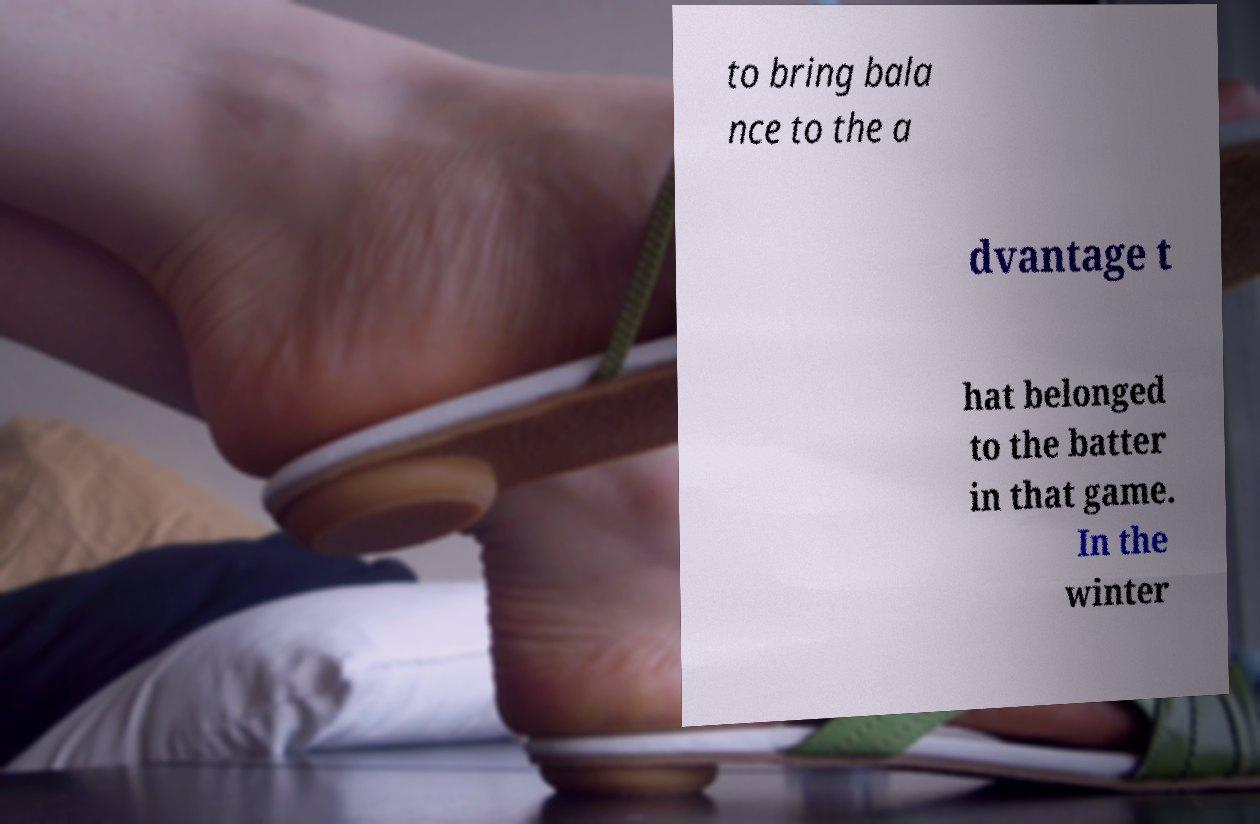For documentation purposes, I need the text within this image transcribed. Could you provide that? to bring bala nce to the a dvantage t hat belonged to the batter in that game. In the winter 